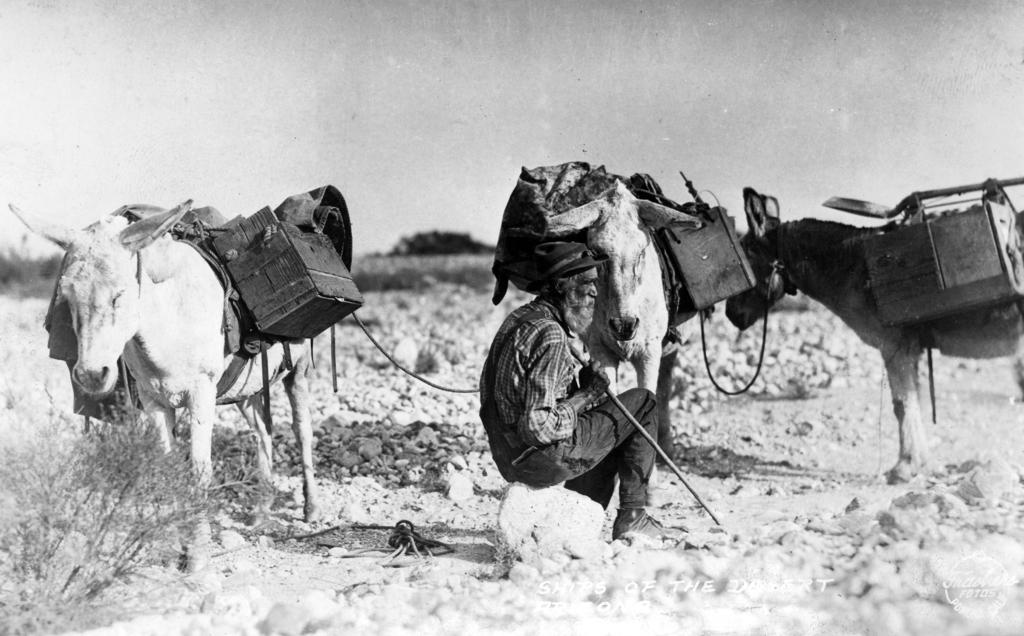What is the color scheme of the image? The image is black and white. What is the man in the image doing? The man is sitting on a rock. What can be seen in the background of the image? There are donkeys in the background. What are the donkeys carrying? The donkeys are carrying luggage. Where is the plant located in the image? The plant is in the bottom left corner of the image. What degree of difficulty is the man experiencing while sitting on the rock in the image? The image does not provide any information about the man's experience or the difficulty of his action, so we cannot determine the degree of difficulty. What type of pleasure can be seen on the man's face in the image? The image is black and white, and there is no indication of the man's facial expression, so we cannot determine the type of pleasure he might be experiencing. 